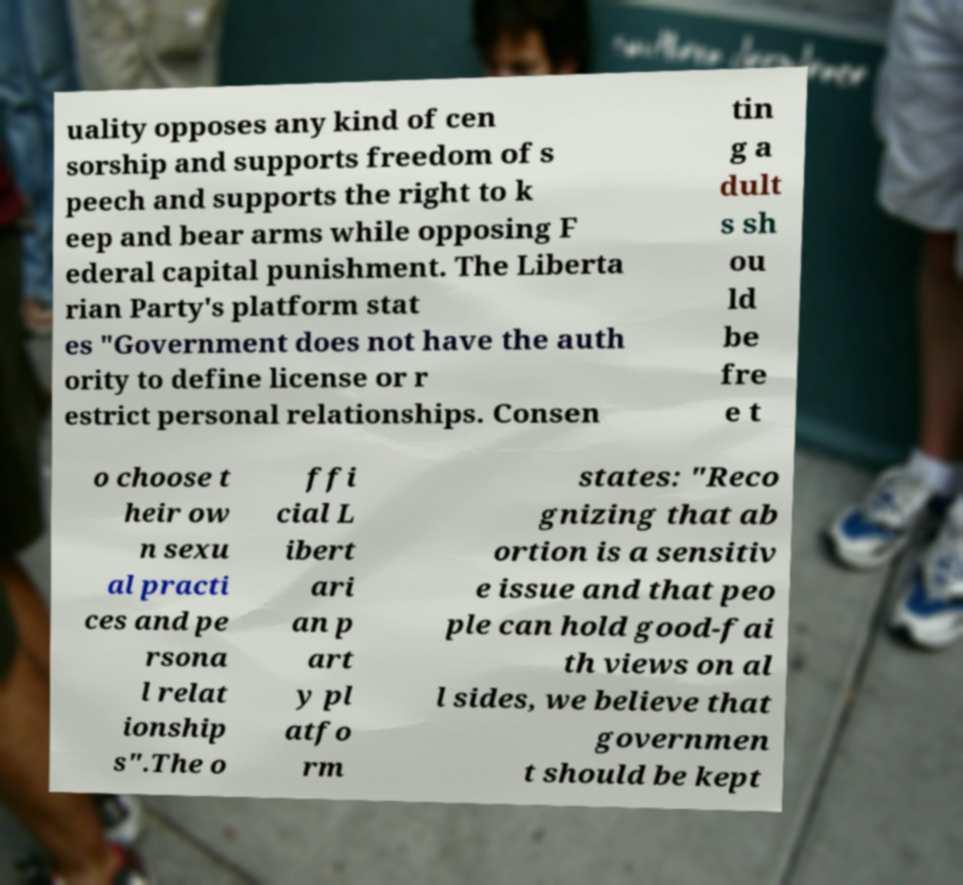For documentation purposes, I need the text within this image transcribed. Could you provide that? uality opposes any kind of cen sorship and supports freedom of s peech and supports the right to k eep and bear arms while opposing F ederal capital punishment. The Liberta rian Party's platform stat es "Government does not have the auth ority to define license or r estrict personal relationships. Consen tin g a dult s sh ou ld be fre e t o choose t heir ow n sexu al practi ces and pe rsona l relat ionship s".The o ffi cial L ibert ari an p art y pl atfo rm states: "Reco gnizing that ab ortion is a sensitiv e issue and that peo ple can hold good-fai th views on al l sides, we believe that governmen t should be kept 